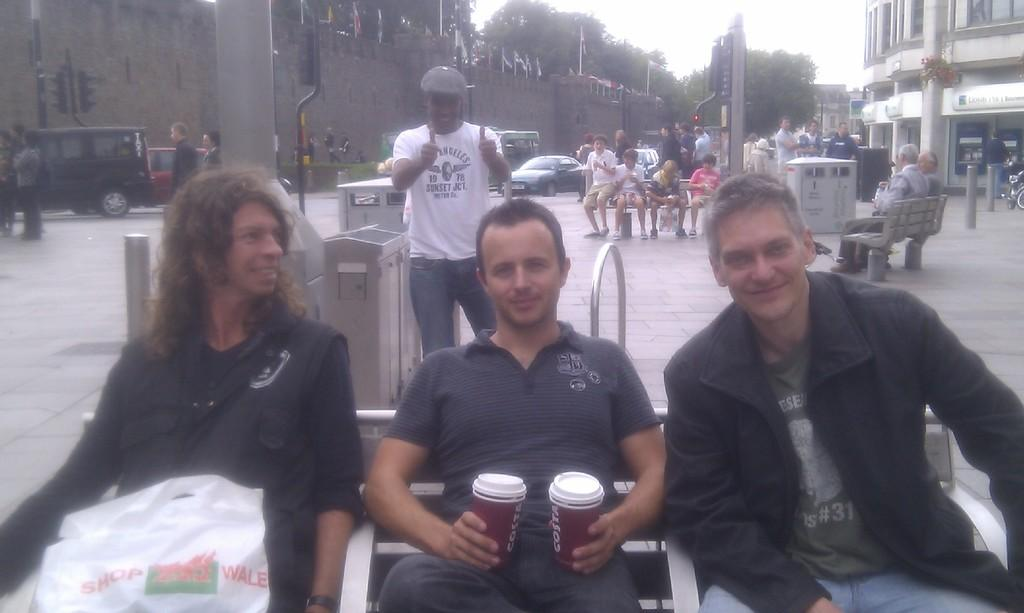What are the people in the image doing? The people in the image are sitting on benches. Can you describe the people in the background of the image? There are people standing in the background of the image. What else can be seen in the background of the image? Cars, at least one building, trees, and the sky are visible in the background of the image. How many beds are visible in the image? There are no beds visible in the image. What type of houses can be seen in the background of the image? There are no houses visible in the image; only a building is mentioned. 